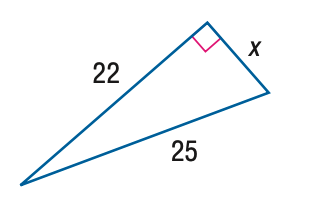Answer the mathemtical geometry problem and directly provide the correct option letter.
Question: Find x.
Choices: A: 10 B: \sqrt { 141 } C: 12 D: 7 \sqrt { 3 } B 